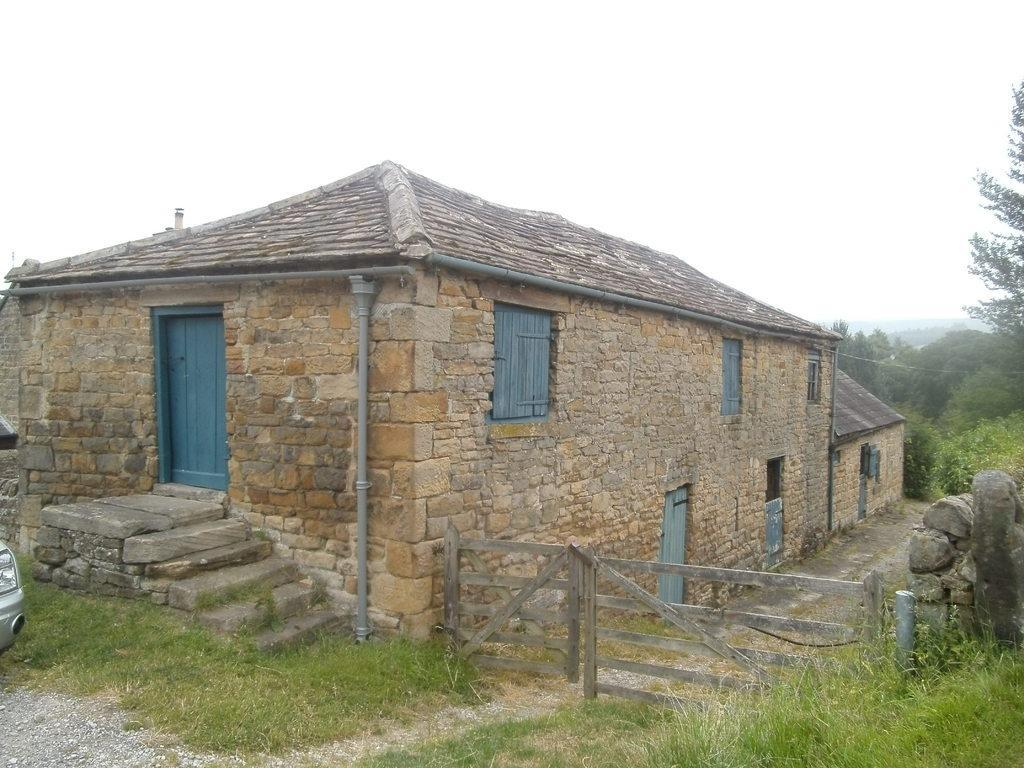Describe this image in one or two sentences. In this image we can see house with blue color door and windows and wooden gate. Bottom of the image grass is there. Right side of the image trees are present with stone wall. At the top white color sky is there. 